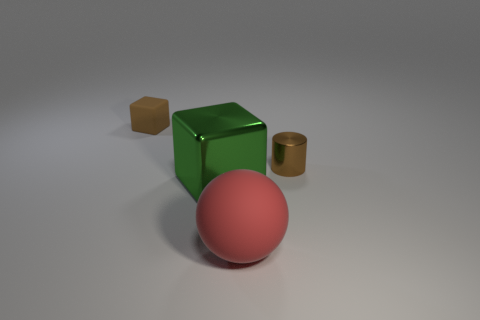Add 4 red objects. How many objects exist? 8 Subtract all cylinders. How many objects are left? 3 Subtract 0 green balls. How many objects are left? 4 Subtract 1 spheres. How many spheres are left? 0 Subtract all yellow blocks. Subtract all blue spheres. How many blocks are left? 2 Subtract all brown cylinders. How many green blocks are left? 1 Subtract all cubes. Subtract all tiny red metallic spheres. How many objects are left? 2 Add 2 rubber balls. How many rubber balls are left? 3 Add 2 big gray spheres. How many big gray spheres exist? 2 Subtract all green blocks. How many blocks are left? 1 